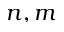Convert formula to latex. <formula><loc_0><loc_0><loc_500><loc_500>n , m</formula> 